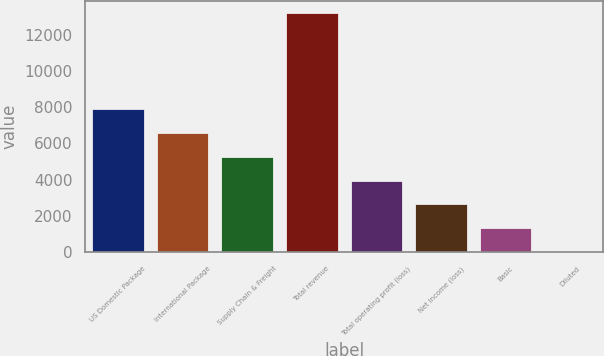Convert chart. <chart><loc_0><loc_0><loc_500><loc_500><bar_chart><fcel>US Domestic Package<fcel>International Package<fcel>Supply Chain & Freight<fcel>Total revenue<fcel>Total operating profit (loss)<fcel>Net income (loss)<fcel>Basic<fcel>Diluted<nl><fcel>7915.03<fcel>6596.04<fcel>5277.05<fcel>13191<fcel>3958.06<fcel>2639.07<fcel>1320.08<fcel>1.09<nl></chart> 